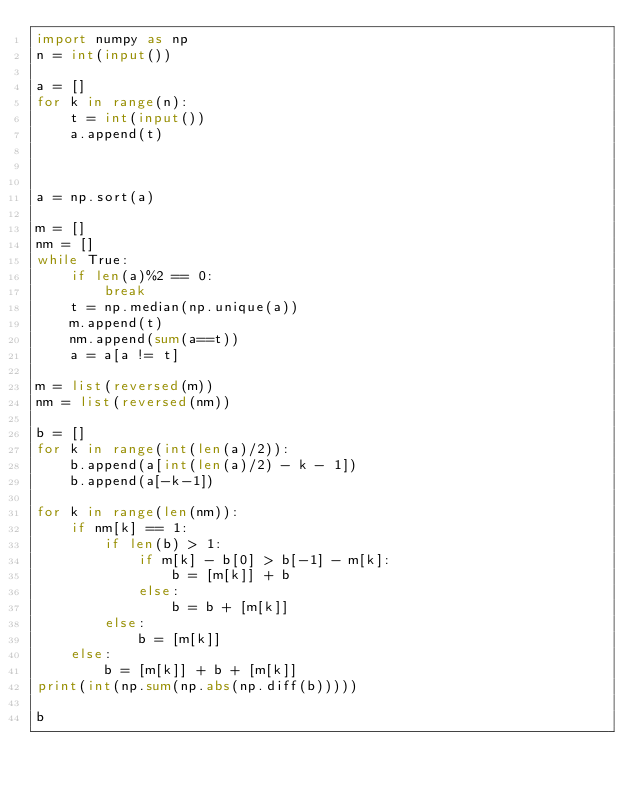Convert code to text. <code><loc_0><loc_0><loc_500><loc_500><_Python_>import numpy as np
n = int(input())

a = []
for k in range(n):
    t = int(input())
    a.append(t)



a = np.sort(a)

m = []
nm = []
while True:
    if len(a)%2 == 0:
        break
    t = np.median(np.unique(a))
    m.append(t)
    nm.append(sum(a==t))
    a = a[a != t]
    
m = list(reversed(m))
nm = list(reversed(nm))

b = []
for k in range(int(len(a)/2)):
    b.append(a[int(len(a)/2) - k - 1])
    b.append(a[-k-1])

for k in range(len(nm)):
    if nm[k] == 1:
        if len(b) > 1:
            if m[k] - b[0] > b[-1] - m[k]:
                b = [m[k]] + b
            else:
                b = b + [m[k]]
        else:
            b = [m[k]]
    else:
        b = [m[k]] + b + [m[k]]
print(int(np.sum(np.abs(np.diff(b)))))

b</code> 